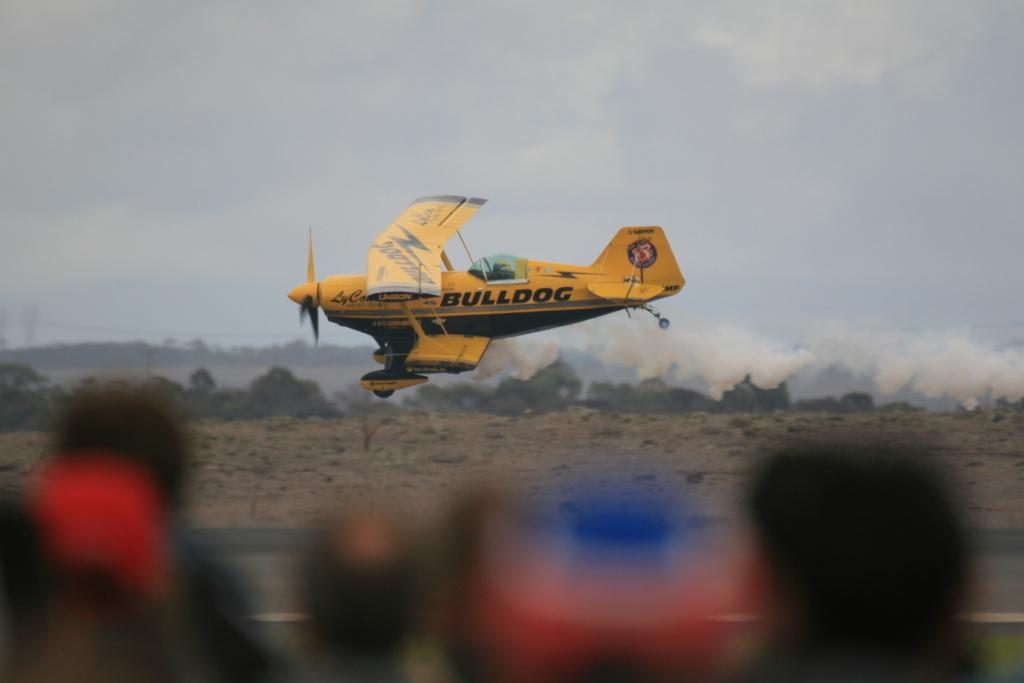What is visible in the background of the image? In the background of the image, there are many trees, clouds, and the sky. Can you describe the aircraft in the image? The aircraft is in the air in the background of the image. What is the condition of the people in the image? The people in the image are blurred. What is the primary subject of the image? The primary subject of the image is the blurred people. Where is the baby sitting on the desk in the image? There is no baby or desk present in the image. What type of exchange is taking place between the people in the image? There is no exchange taking place between the people in the image, as they are blurred and not interacting with each other. 